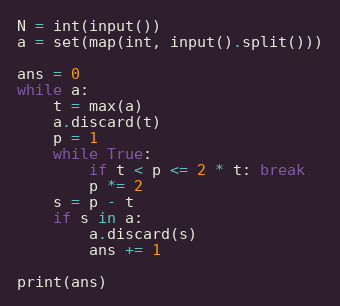Convert code to text. <code><loc_0><loc_0><loc_500><loc_500><_Python_>N = int(input())
a = set(map(int, input().split()))

ans = 0
while a:
    t = max(a)
    a.discard(t)
    p = 1
    while True:
        if t < p <= 2 * t: break
        p *= 2
    s = p - t
    if s in a:
        a.discard(s)
        ans += 1

print(ans)
</code> 